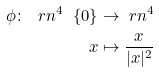Convert formula to latex. <formula><loc_0><loc_0><loc_500><loc_500>\phi \colon \ r n ^ { 4 } \ \{ 0 \} & \to \ r n ^ { 4 } \\ x & \mapsto \frac { x } { | x | ^ { 2 } }</formula> 